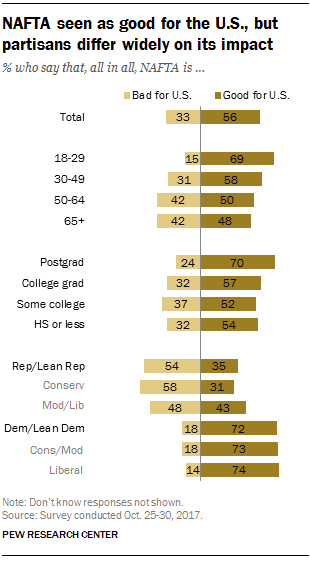List a handful of essential elements in this visual. The value of the rightmost bar is greater than the largest value of the leftmost bar by 5. 